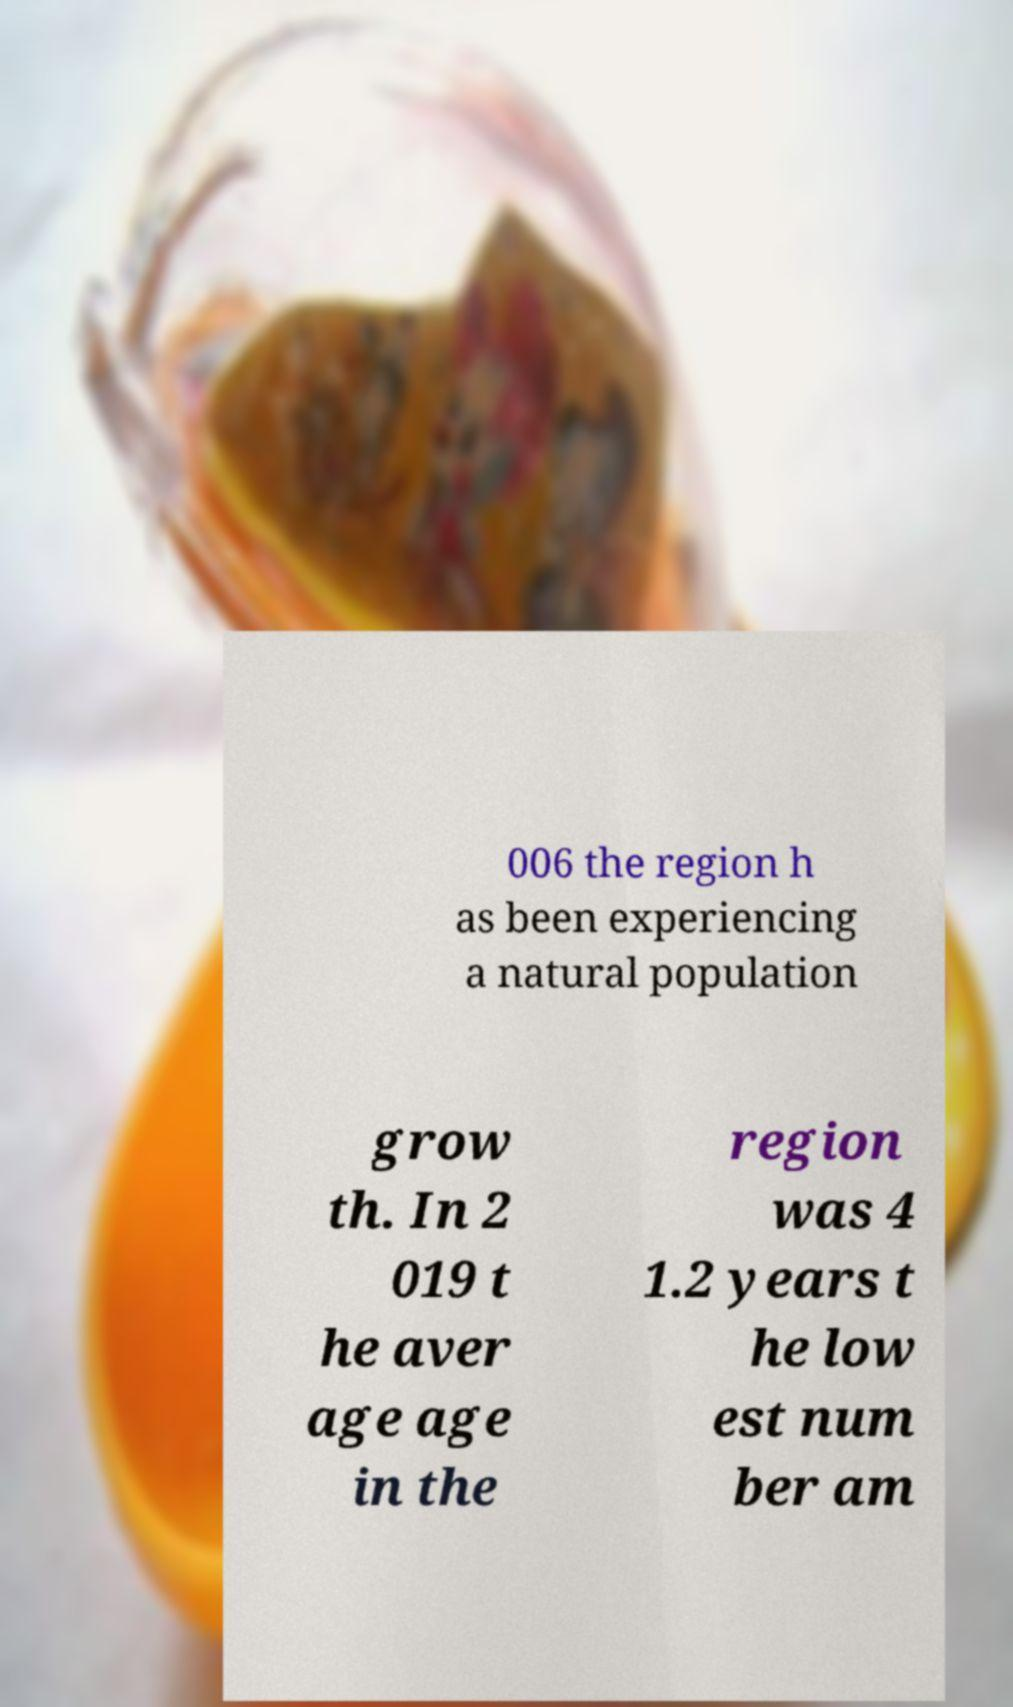For documentation purposes, I need the text within this image transcribed. Could you provide that? 006 the region h as been experiencing a natural population grow th. In 2 019 t he aver age age in the region was 4 1.2 years t he low est num ber am 